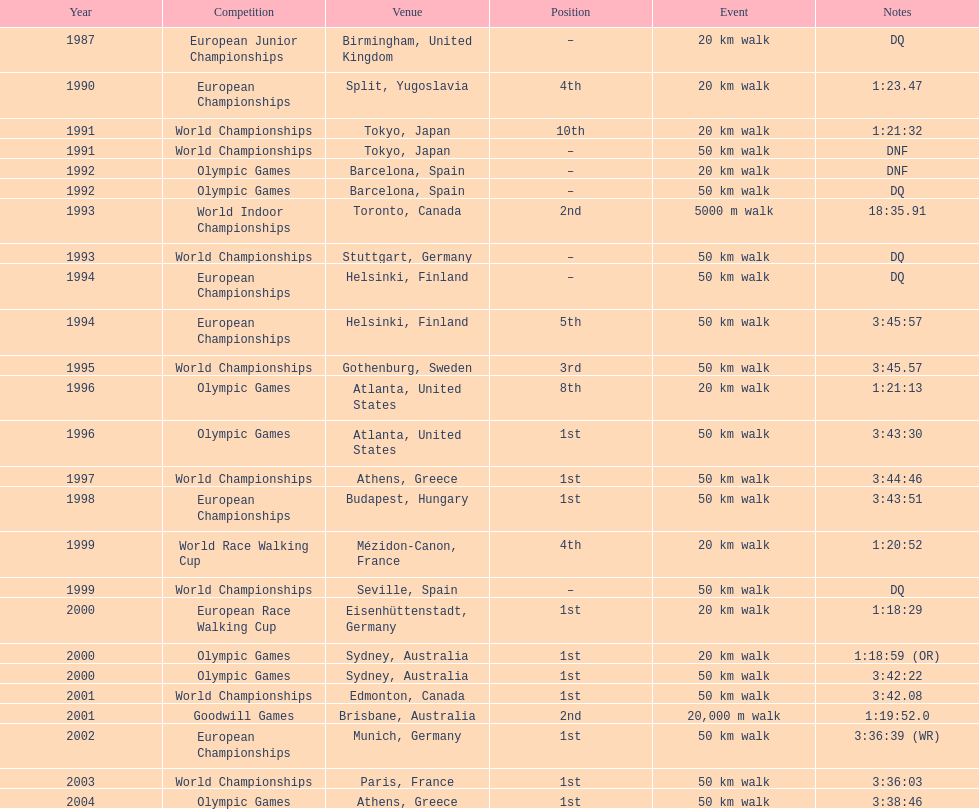Which location is mentioned the most? Athens, Greece. 